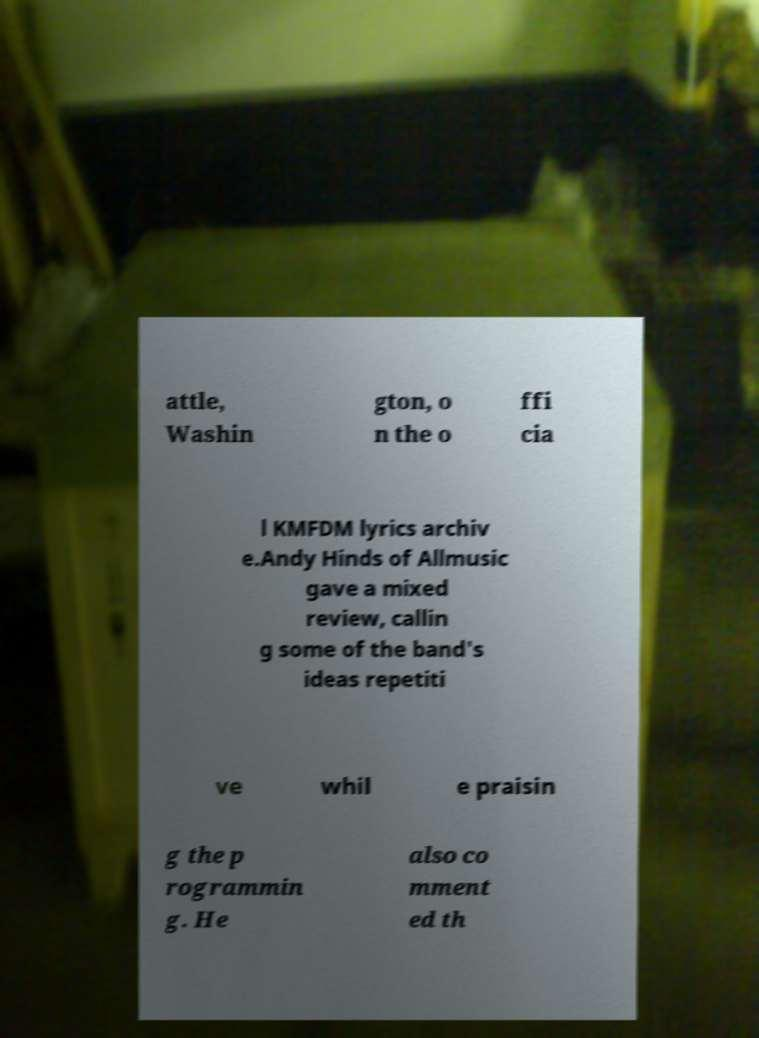Please identify and transcribe the text found in this image. attle, Washin gton, o n the o ffi cia l KMFDM lyrics archiv e.Andy Hinds of Allmusic gave a mixed review, callin g some of the band's ideas repetiti ve whil e praisin g the p rogrammin g. He also co mment ed th 